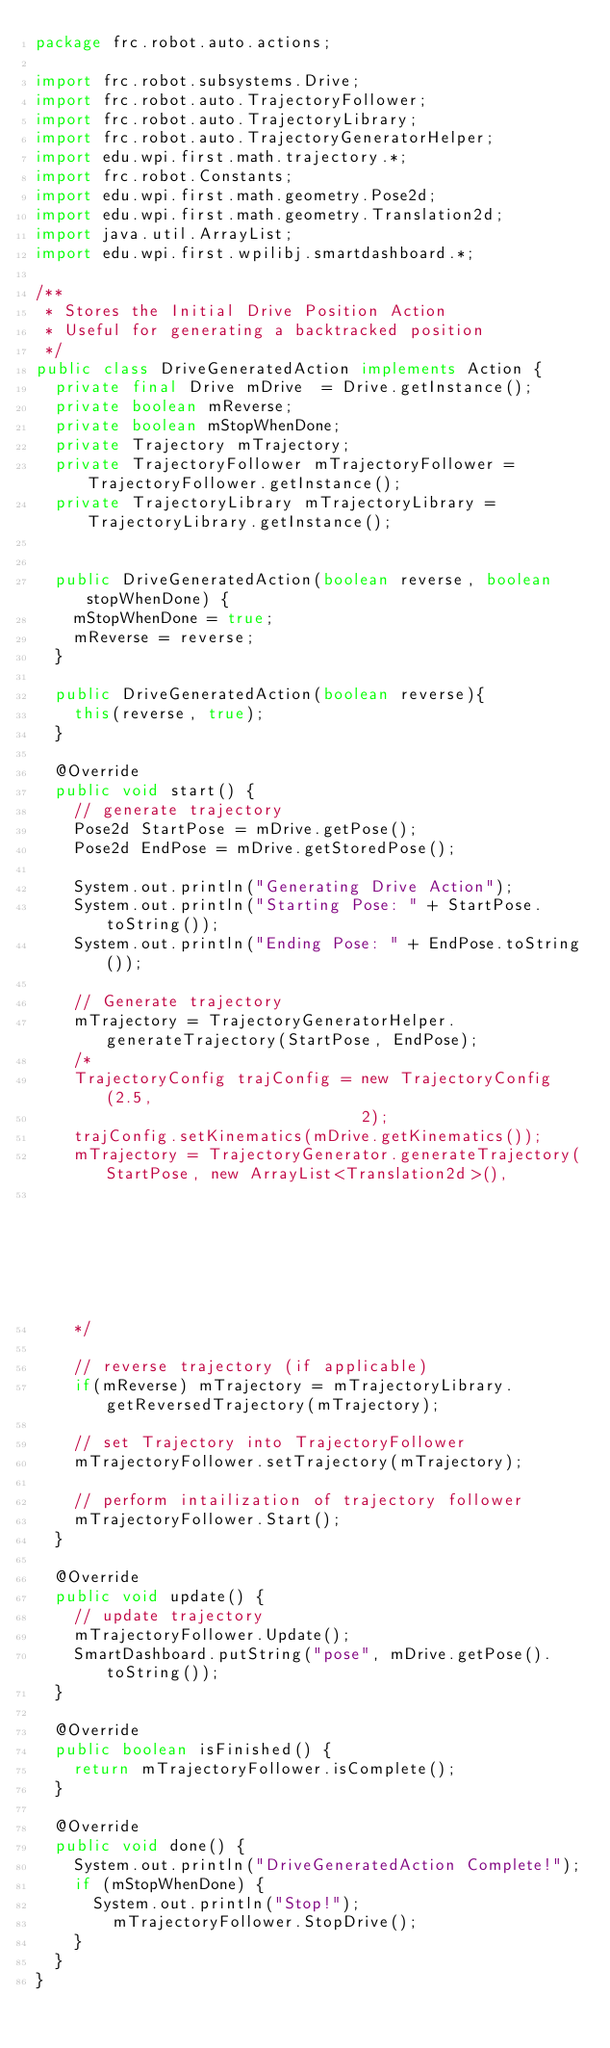<code> <loc_0><loc_0><loc_500><loc_500><_Java_>package frc.robot.auto.actions;

import frc.robot.subsystems.Drive;
import frc.robot.auto.TrajectoryFollower;
import frc.robot.auto.TrajectoryLibrary;
import frc.robot.auto.TrajectoryGeneratorHelper;
import edu.wpi.first.math.trajectory.*;
import frc.robot.Constants;
import edu.wpi.first.math.geometry.Pose2d;
import edu.wpi.first.math.geometry.Translation2d;
import java.util.ArrayList;
import edu.wpi.first.wpilibj.smartdashboard.*;

/**
 * Stores the Initial Drive Position Action
 * Useful for generating a backtracked position
 */
public class DriveGeneratedAction implements Action {
  private final Drive mDrive  = Drive.getInstance();
  private boolean mReverse;
  private boolean mStopWhenDone;
  private Trajectory mTrajectory;
  private TrajectoryFollower mTrajectoryFollower = TrajectoryFollower.getInstance();
  private TrajectoryLibrary mTrajectoryLibrary = TrajectoryLibrary.getInstance();


  public DriveGeneratedAction(boolean reverse, boolean stopWhenDone) {
    mStopWhenDone = true;
    mReverse = reverse;
  }

  public DriveGeneratedAction(boolean reverse){
    this(reverse, true);
  }

  @Override
  public void start() {
    // generate trajectory
    Pose2d StartPose = mDrive.getPose();
    Pose2d EndPose = mDrive.getStoredPose();

    System.out.println("Generating Drive Action");
    System.out.println("Starting Pose: " + StartPose.toString());
    System.out.println("Ending Pose: " + EndPose.toString());

    // Generate trajectory
    mTrajectory = TrajectoryGeneratorHelper.generateTrajectory(StartPose, EndPose);
    /*
    TrajectoryConfig trajConfig = new TrajectoryConfig(2.5, 
                                  2);
    trajConfig.setKinematics(mDrive.getKinematics());
    mTrajectory = TrajectoryGenerator.generateTrajectory(StartPose, new ArrayList<Translation2d>(), 
                                                                    EndPose, trajConfig);
    */
    
    // reverse trajectory (if applicable)
    if(mReverse) mTrajectory = mTrajectoryLibrary.getReversedTrajectory(mTrajectory);

    // set Trajectory into TrajectoryFollower
    mTrajectoryFollower.setTrajectory(mTrajectory);

    // perform intailization of trajectory follower
    mTrajectoryFollower.Start();
  }

  @Override
  public void update() {
    // update trajectory
    mTrajectoryFollower.Update();
    SmartDashboard.putString("pose", mDrive.getPose().toString());
  }

  @Override
  public boolean isFinished() {
    return mTrajectoryFollower.isComplete();
  }

  @Override
  public void done() {
    System.out.println("DriveGeneratedAction Complete!");
    if (mStopWhenDone) {
      System.out.println("Stop!");
        mTrajectoryFollower.StopDrive();
    }
  }
}
</code> 